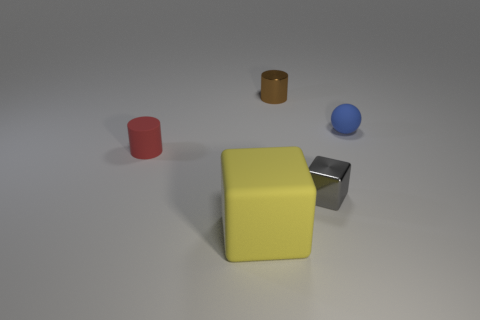Is there anything else that has the same size as the yellow block?
Provide a short and direct response. No. Does the large thing have the same material as the block right of the small brown shiny cylinder?
Your response must be concise. No. There is a metallic object in front of the small object on the left side of the yellow object; what is its color?
Provide a succinct answer. Gray. Are there any big shiny blocks of the same color as the small sphere?
Ensure brevity in your answer.  No. There is a matte thing in front of the small cylinder that is in front of the tiny cylinder on the right side of the tiny red rubber cylinder; how big is it?
Provide a succinct answer. Large. There is a red matte thing; is it the same shape as the small metallic thing that is behind the rubber cylinder?
Your response must be concise. Yes. What number of other things are the same size as the matte block?
Keep it short and to the point. 0. There is a rubber thing right of the yellow matte object; what size is it?
Keep it short and to the point. Small. How many objects have the same material as the gray cube?
Make the answer very short. 1. There is a tiny thing on the left side of the big block; is it the same shape as the yellow thing?
Offer a terse response. No. 